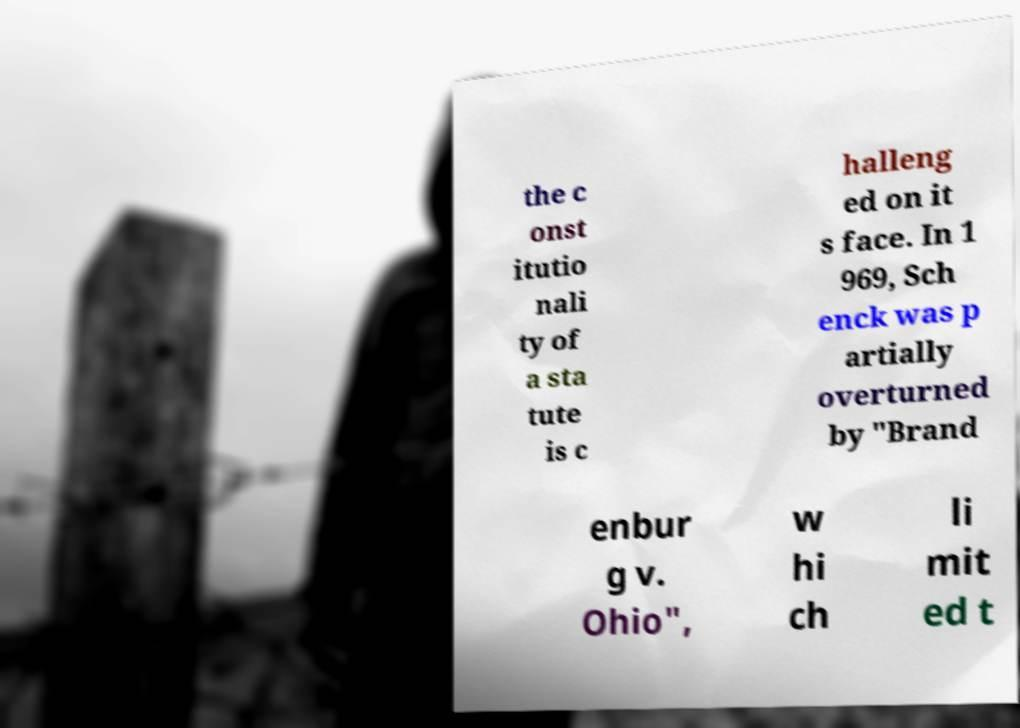Can you accurately transcribe the text from the provided image for me? the c onst itutio nali ty of a sta tute is c halleng ed on it s face. In 1 969, Sch enck was p artially overturned by "Brand enbur g v. Ohio", w hi ch li mit ed t 